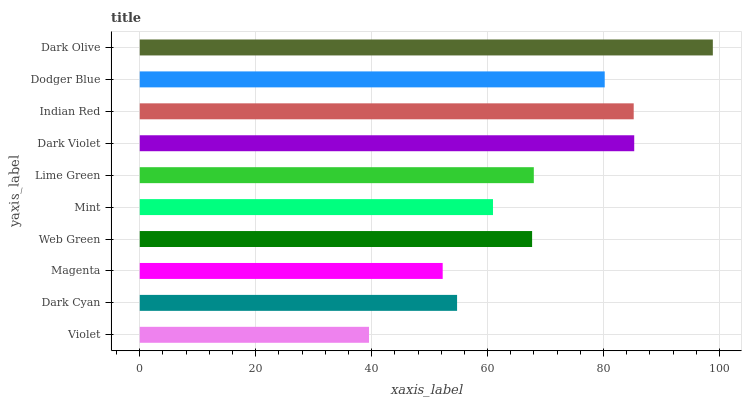Is Violet the minimum?
Answer yes or no. Yes. Is Dark Olive the maximum?
Answer yes or no. Yes. Is Dark Cyan the minimum?
Answer yes or no. No. Is Dark Cyan the maximum?
Answer yes or no. No. Is Dark Cyan greater than Violet?
Answer yes or no. Yes. Is Violet less than Dark Cyan?
Answer yes or no. Yes. Is Violet greater than Dark Cyan?
Answer yes or no. No. Is Dark Cyan less than Violet?
Answer yes or no. No. Is Lime Green the high median?
Answer yes or no. Yes. Is Web Green the low median?
Answer yes or no. Yes. Is Dodger Blue the high median?
Answer yes or no. No. Is Lime Green the low median?
Answer yes or no. No. 